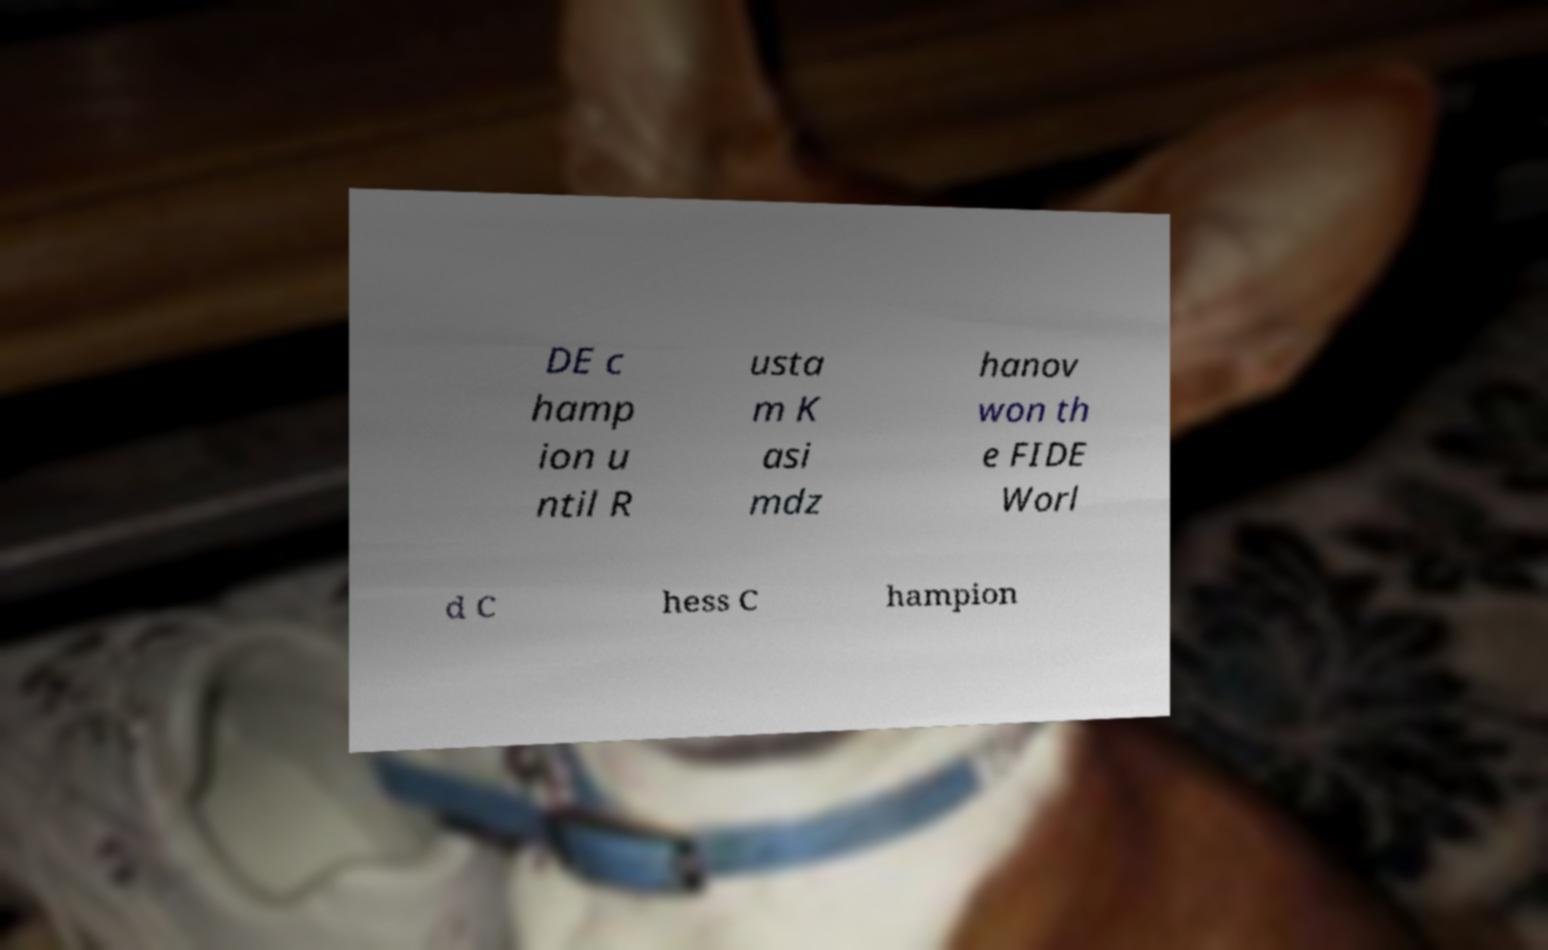Can you accurately transcribe the text from the provided image for me? DE c hamp ion u ntil R usta m K asi mdz hanov won th e FIDE Worl d C hess C hampion 